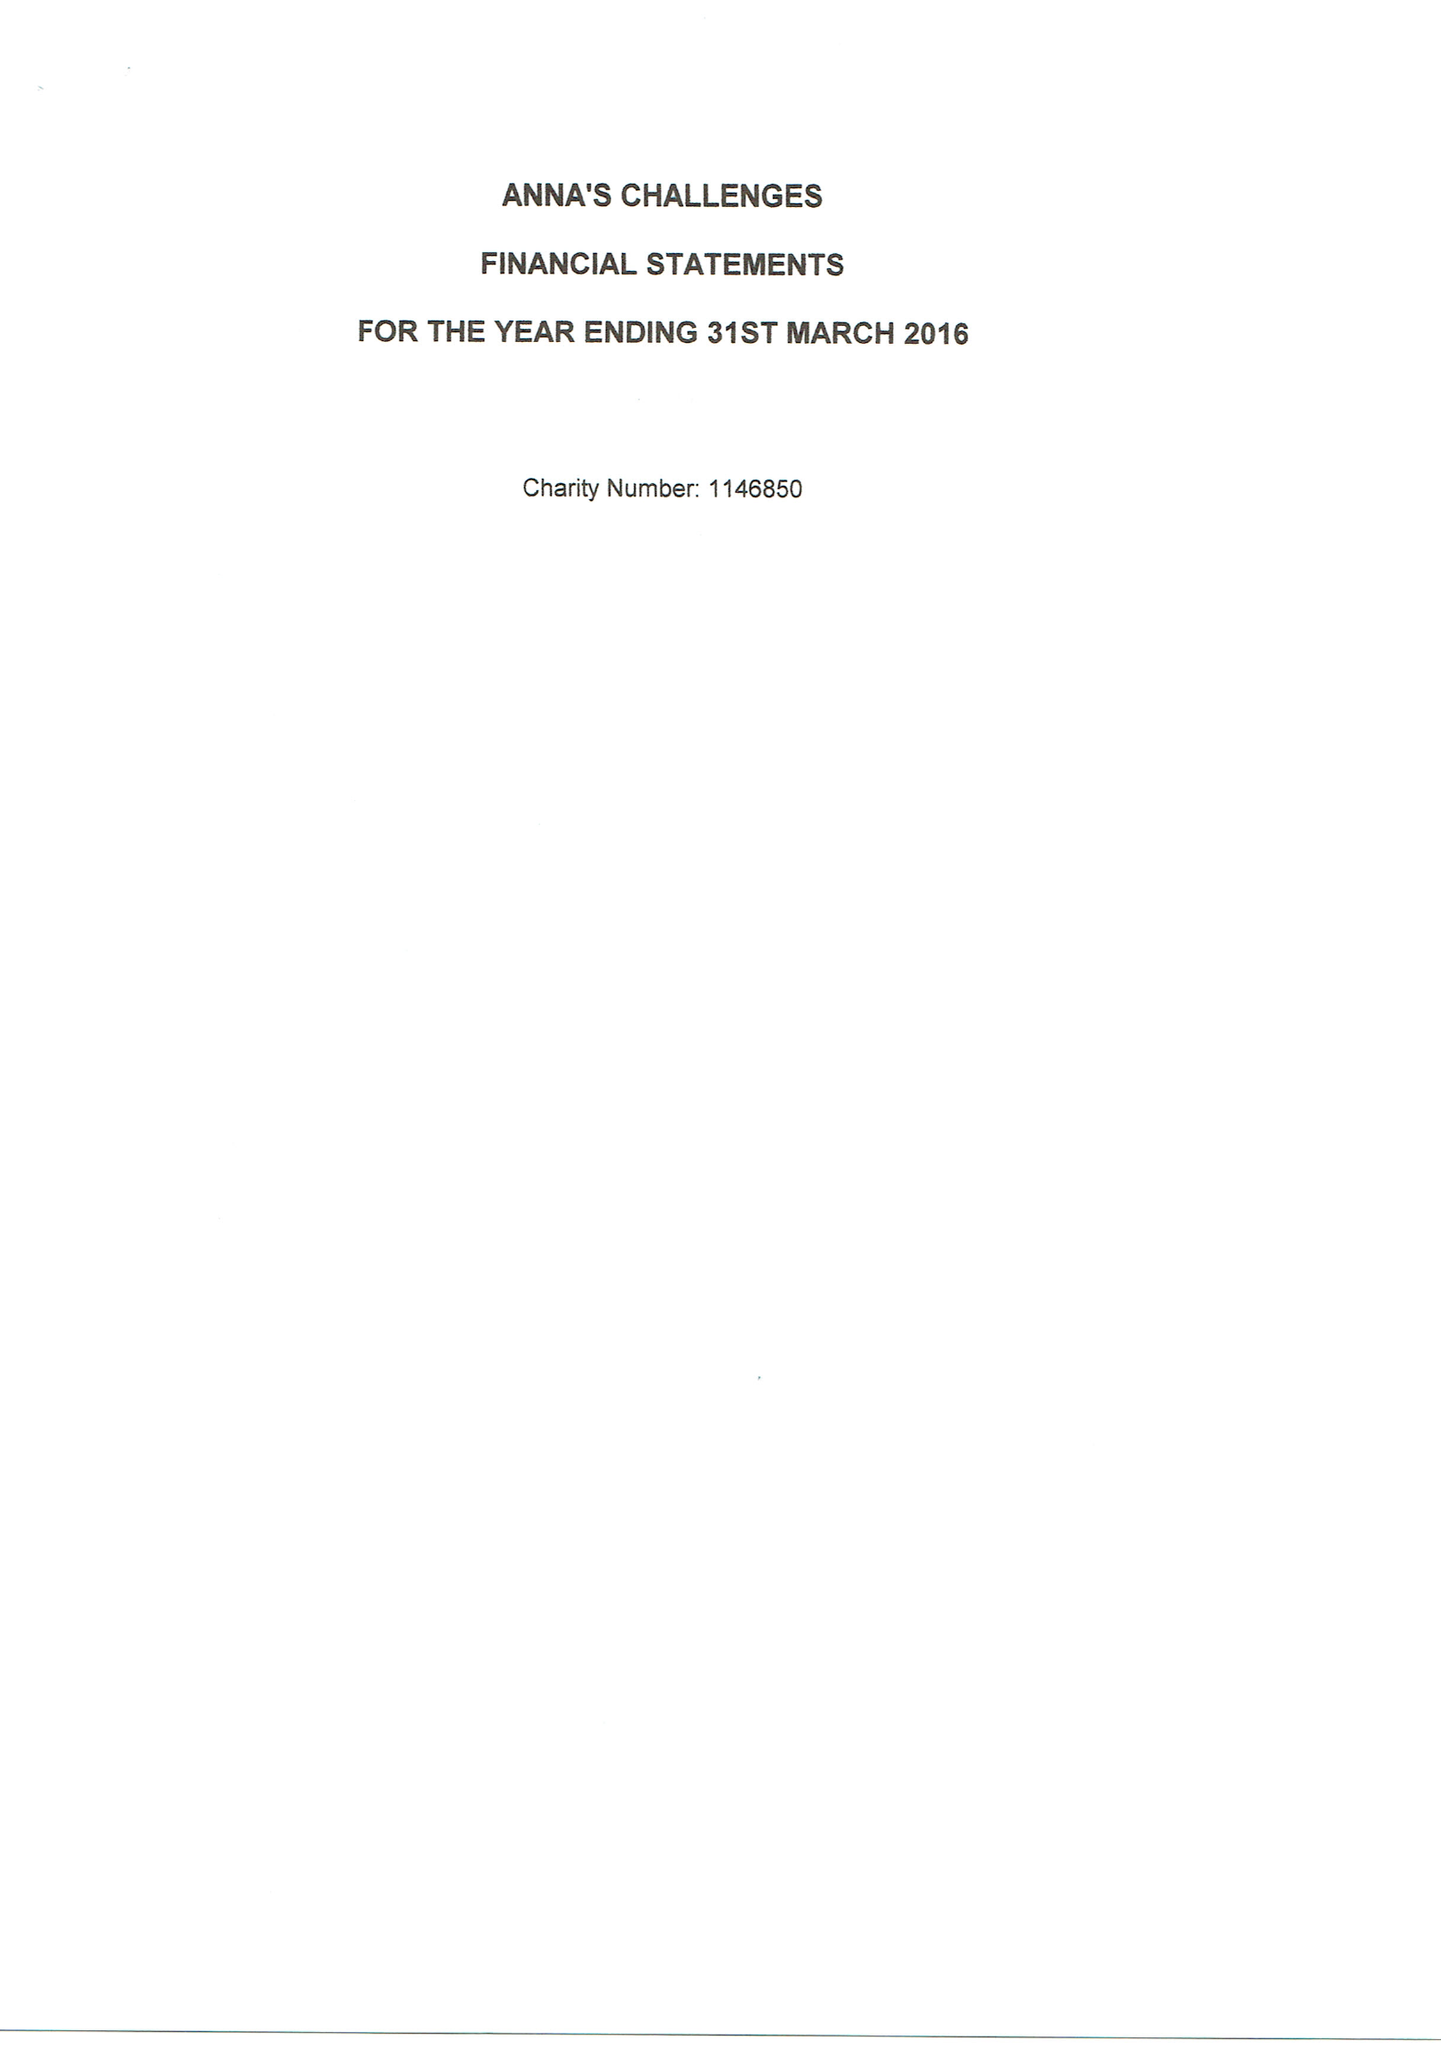What is the value for the charity_name?
Answer the question using a single word or phrase. Anna's Challenges 